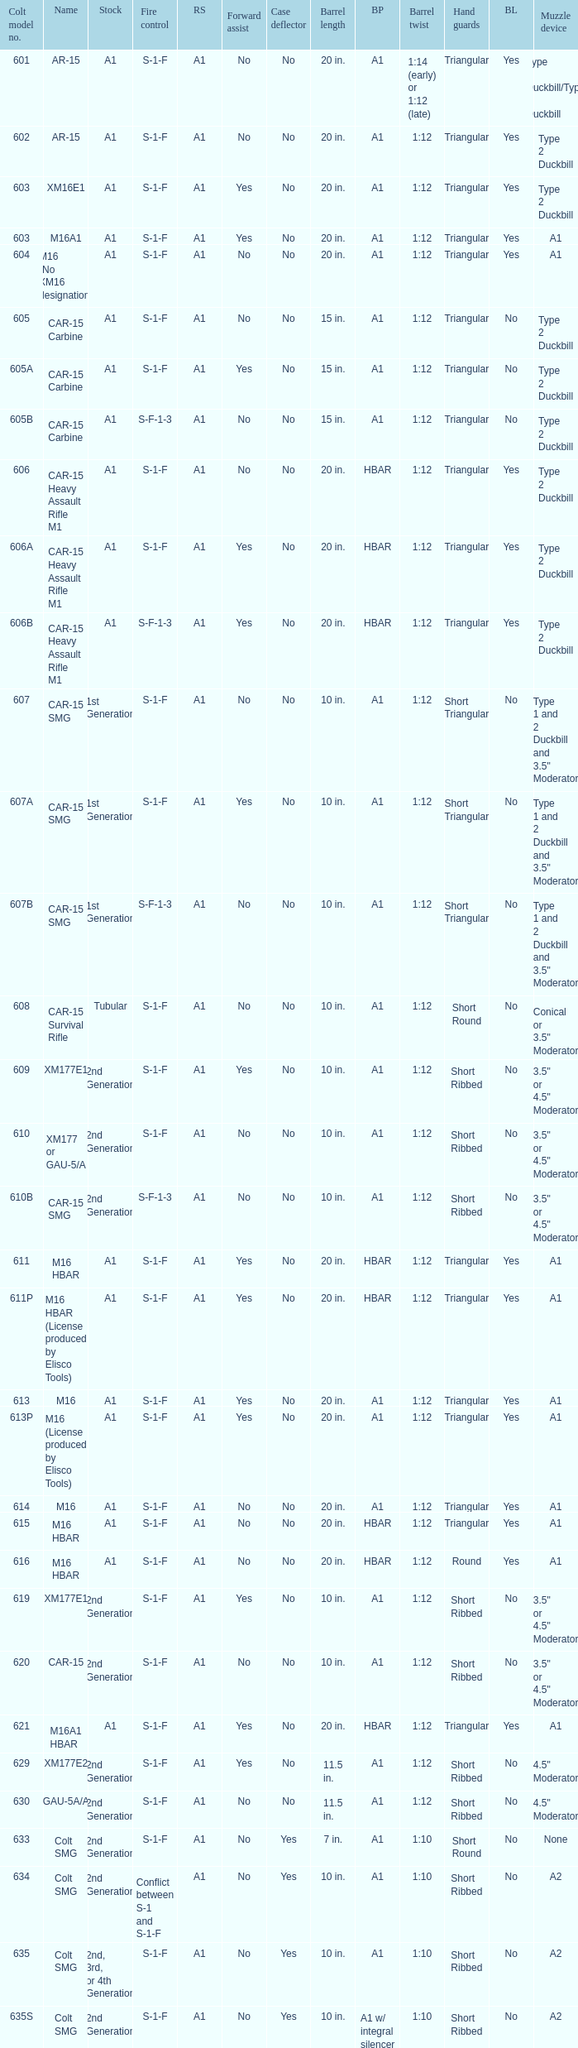What are the Colt model numbers of the models named GAU-5A/A, with no bayonet lug, no case deflector and stock of 2nd generation?  630, 649. 